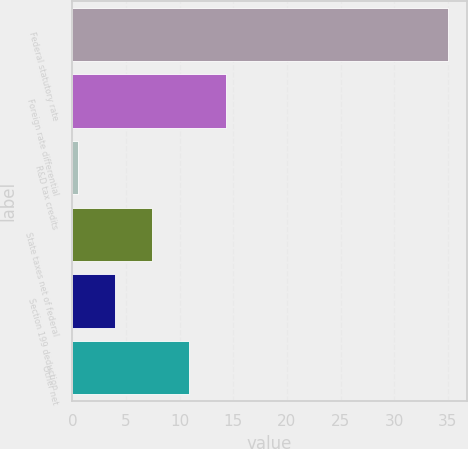Convert chart to OTSL. <chart><loc_0><loc_0><loc_500><loc_500><bar_chart><fcel>Federal statutory rate<fcel>Foreign rate differential<fcel>R&D tax credits<fcel>State taxes net of federal<fcel>Section 199 deduction<fcel>Other net<nl><fcel>35<fcel>14.3<fcel>0.5<fcel>7.4<fcel>3.95<fcel>10.85<nl></chart> 